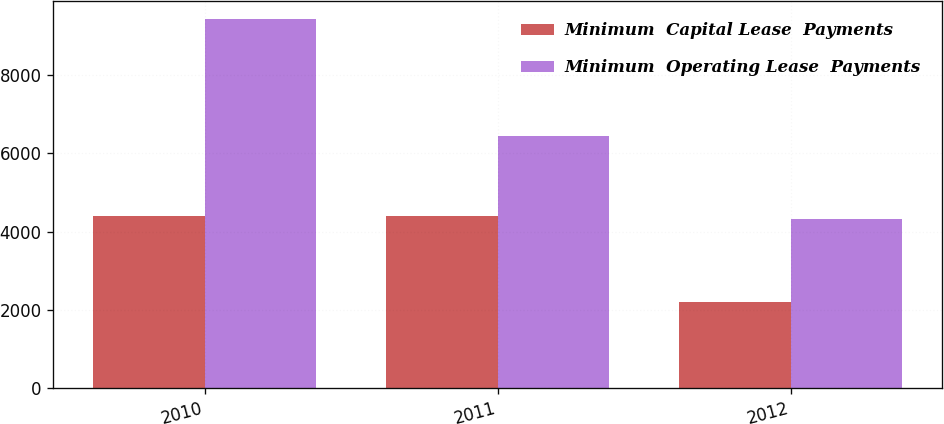Convert chart to OTSL. <chart><loc_0><loc_0><loc_500><loc_500><stacked_bar_chart><ecel><fcel>2010<fcel>2011<fcel>2012<nl><fcel>Minimum  Capital Lease  Payments<fcel>4400<fcel>4401<fcel>2197<nl><fcel>Minimum  Operating Lease  Payments<fcel>9433<fcel>6436<fcel>4325<nl></chart> 